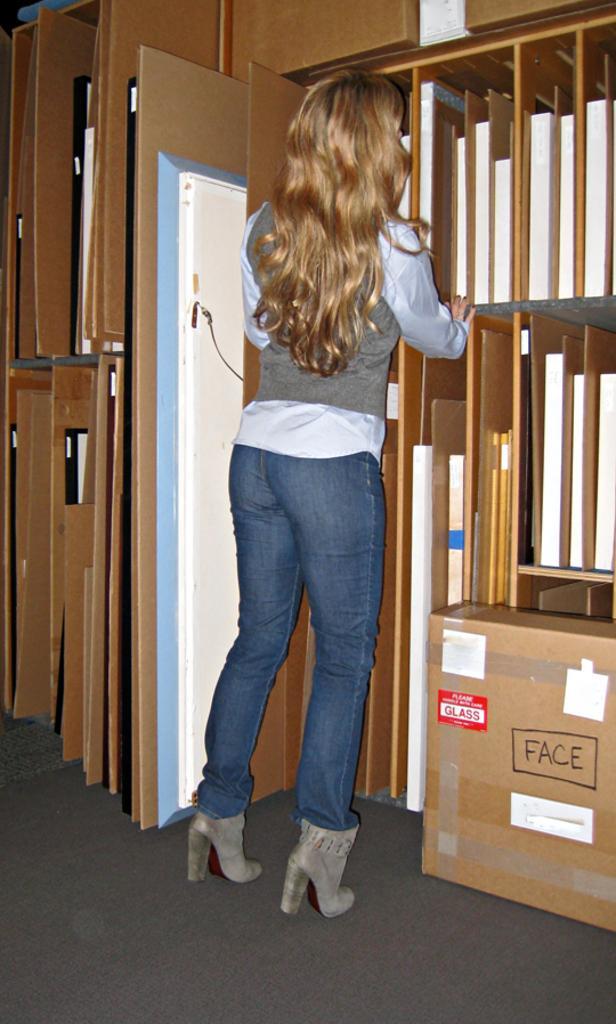Could you give a brief overview of what you see in this image? In the middle of the image we can see a woman, in front of her we can find few wooden planks, on the right side of the image we can see a box. 